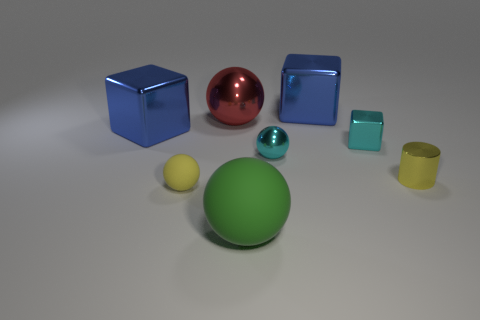How many large blue things are to the left of the big ball in front of the small metal cylinder?
Offer a terse response. 1. What is the shape of the big blue metallic thing in front of the large blue metallic block that is right of the large ball behind the small metallic cylinder?
Keep it short and to the point. Cube. There is a shiny object that is the same color as the small rubber object; what is its size?
Offer a very short reply. Small. How many objects are cyan spheres or yellow balls?
Your answer should be very brief. 2. What color is the matte object that is the same size as the yellow shiny cylinder?
Your answer should be compact. Yellow. Is the shape of the red metallic object the same as the thing on the right side of the cyan shiny block?
Make the answer very short. No. What number of objects are tiny objects behind the tiny yellow rubber ball or tiny balls on the left side of the big green object?
Make the answer very short. 4. What is the shape of the thing that is the same color as the tiny cube?
Your answer should be compact. Sphere. What is the shape of the blue shiny thing to the left of the large red ball?
Your response must be concise. Cube. There is a small object to the left of the big rubber ball; is its shape the same as the small yellow metallic object?
Give a very brief answer. No. 